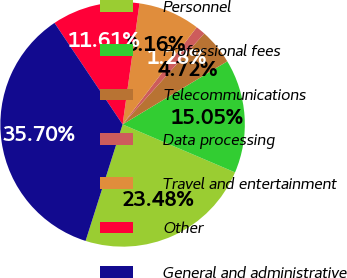Convert chart. <chart><loc_0><loc_0><loc_500><loc_500><pie_chart><fcel>Personnel<fcel>Professional fees<fcel>Telecommunications<fcel>Data processing<fcel>Travel and entertainment<fcel>Other<fcel>General and administrative<nl><fcel>23.48%<fcel>15.05%<fcel>4.72%<fcel>1.28%<fcel>8.16%<fcel>11.61%<fcel>35.7%<nl></chart> 